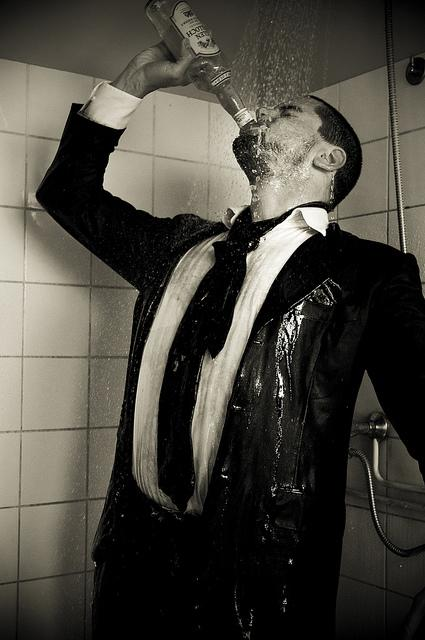What single item is most out of place? Please explain your reasoning. shower. The shower does not belong. 